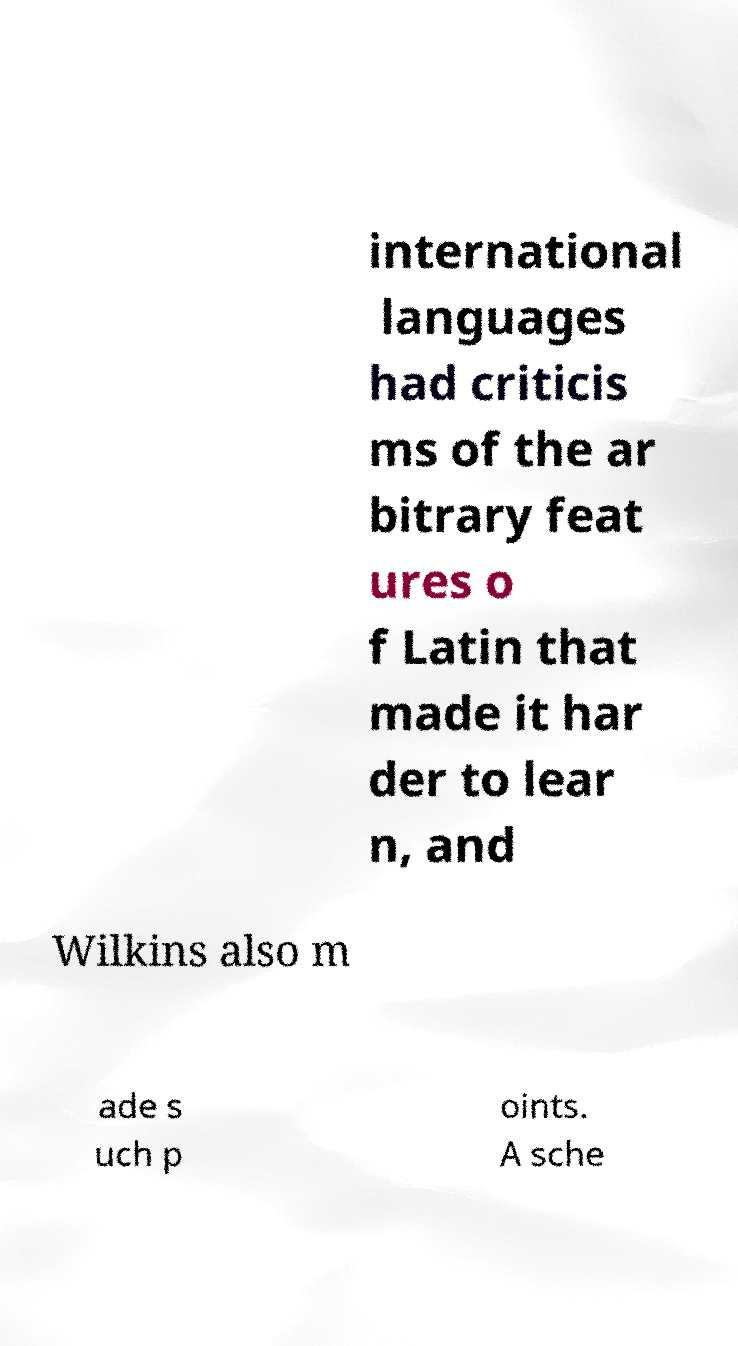Could you extract and type out the text from this image? international languages had criticis ms of the ar bitrary feat ures o f Latin that made it har der to lear n, and Wilkins also m ade s uch p oints. A sche 